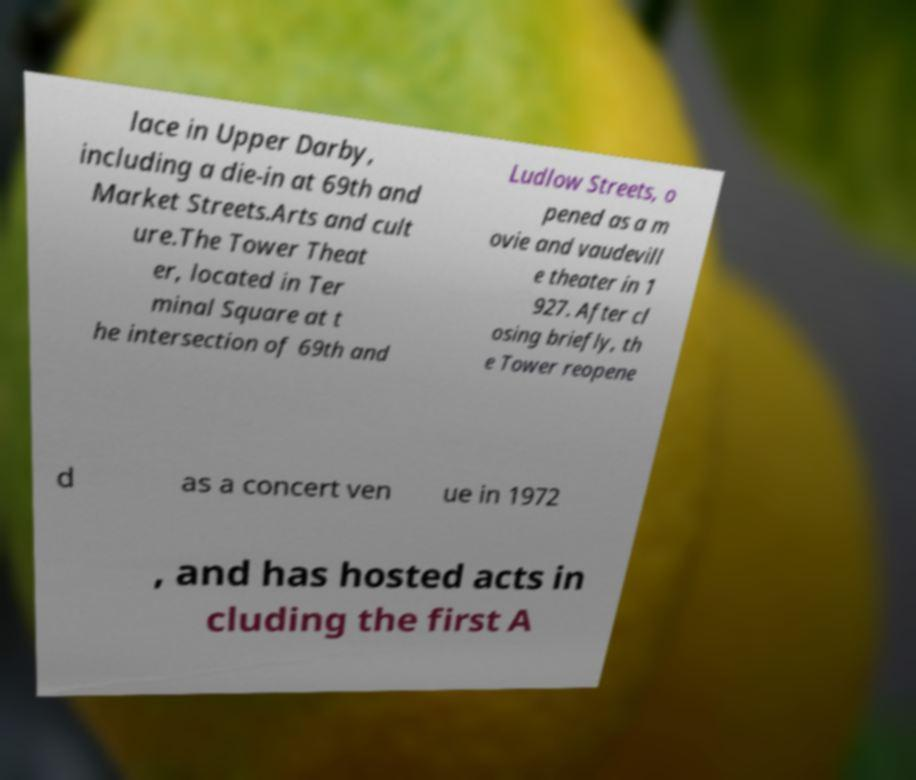I need the written content from this picture converted into text. Can you do that? lace in Upper Darby, including a die-in at 69th and Market Streets.Arts and cult ure.The Tower Theat er, located in Ter minal Square at t he intersection of 69th and Ludlow Streets, o pened as a m ovie and vaudevill e theater in 1 927. After cl osing briefly, th e Tower reopene d as a concert ven ue in 1972 , and has hosted acts in cluding the first A 